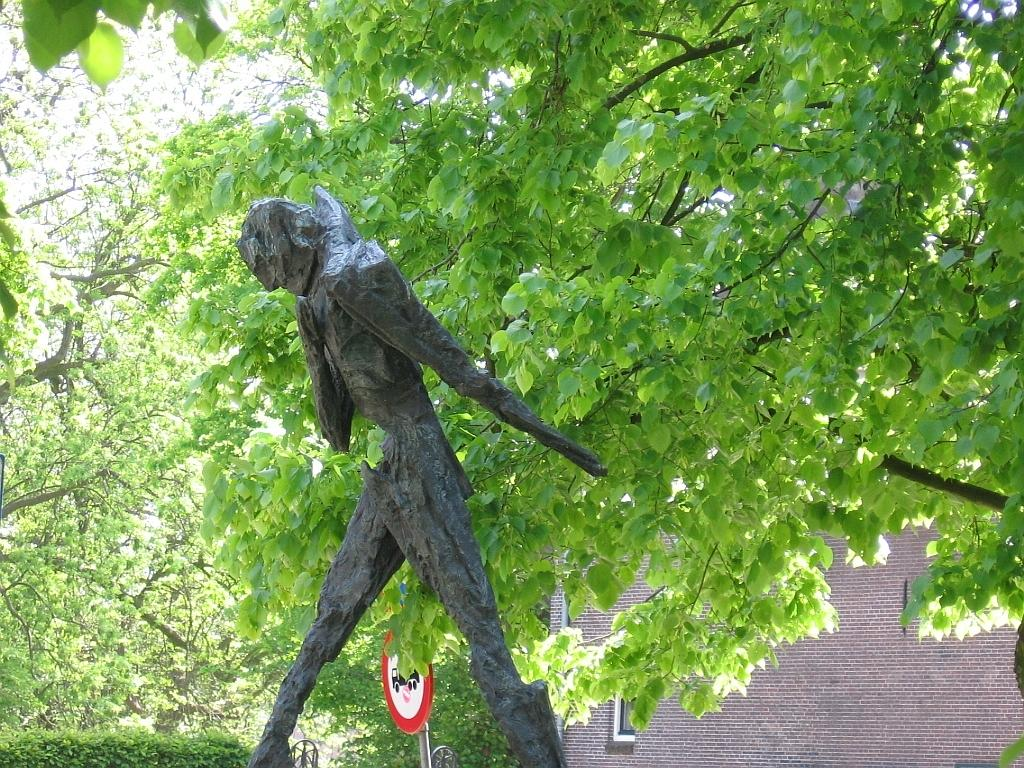What is the main subject in the image? There is a statue in the image. What can be seen in the distance behind the statue? There is a building in the background of the image. What type of vegetation is present around the building in the background? There are trees surrounding the building in the background of the image. Where is the dad in the image? There is no dad present in the image; it only features a statue, a building, and trees. 